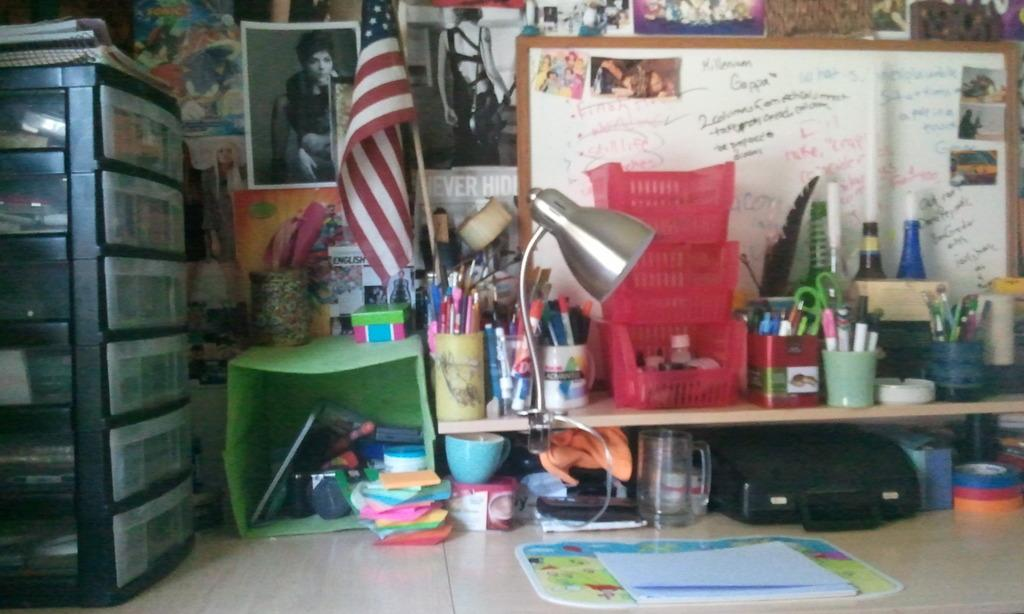<image>
Create a compact narrative representing the image presented. the word ever is in white is near a white board 